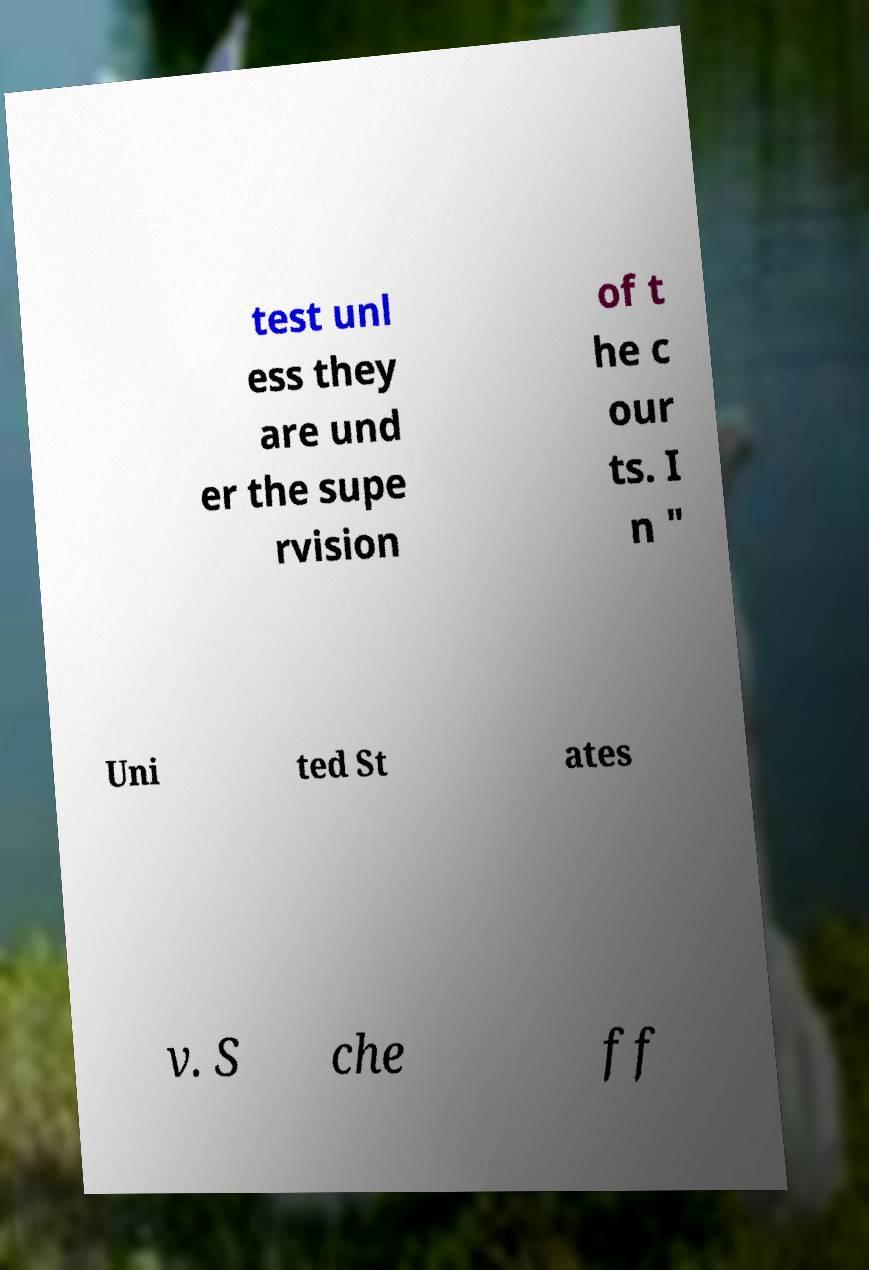For documentation purposes, I need the text within this image transcribed. Could you provide that? test unl ess they are und er the supe rvision of t he c our ts. I n " Uni ted St ates v. S che ff 